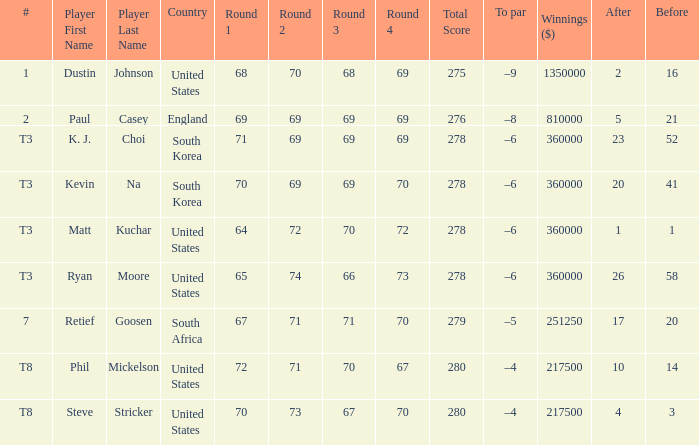What is the score when the player is Matt Kuchar? 64-72-70-72=278. 